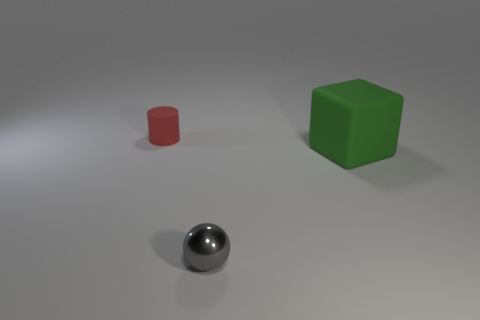Is there any other thing that has the same material as the ball?
Give a very brief answer. No. There is a matte thing that is on the right side of the matte thing left of the tiny gray sphere; is there a red object behind it?
Give a very brief answer. Yes. There is a small ball; are there any small metallic things on the right side of it?
Make the answer very short. No. What number of metal objects are the same color as the small cylinder?
Provide a short and direct response. 0. The block that is the same material as the red cylinder is what size?
Offer a terse response. Large. There is a thing on the right side of the small object that is in front of the rubber object on the left side of the small gray object; what size is it?
Your answer should be compact. Large. There is a matte thing right of the tiny gray shiny ball; how big is it?
Give a very brief answer. Large. How many red objects are either tiny shiny cylinders or small rubber cylinders?
Provide a short and direct response. 1. Are there any other rubber objects that have the same size as the gray object?
Offer a very short reply. Yes. There is a ball that is the same size as the cylinder; what is it made of?
Provide a short and direct response. Metal. 